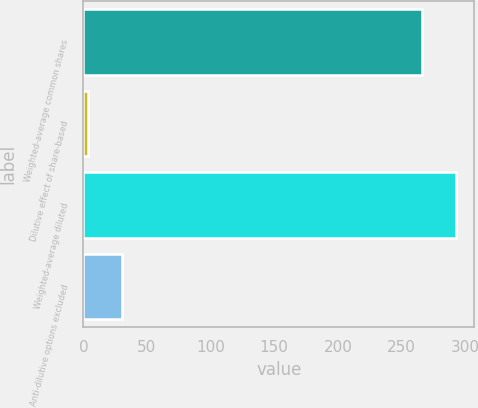Convert chart to OTSL. <chart><loc_0><loc_0><loc_500><loc_500><bar_chart><fcel>Weighted-average common shares<fcel>Dilutive effect of share-based<fcel>Weighted-average diluted<fcel>Anti-dilutive options excluded<nl><fcel>266<fcel>4<fcel>292.6<fcel>30.6<nl></chart> 